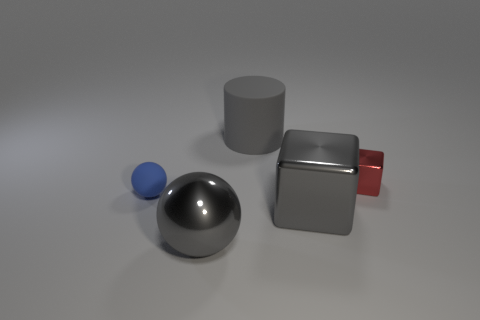Is there any other thing of the same color as the large shiny ball?
Your answer should be compact. Yes. Is the number of big cylinders on the left side of the gray metallic block greater than the number of big green rubber things?
Provide a succinct answer. Yes. How many objects are either things in front of the big cylinder or gray spheres?
Provide a short and direct response. 4. What number of small red cubes have the same material as the large sphere?
Keep it short and to the point. 1. There is a rubber object that is the same color as the big shiny sphere; what shape is it?
Provide a short and direct response. Cylinder. Is there a metallic thing that has the same shape as the blue rubber thing?
Your answer should be compact. Yes. There is a metallic object that is the same size as the gray metal cube; what shape is it?
Offer a very short reply. Sphere. There is a matte cylinder; is its color the same as the block in front of the red metallic block?
Your answer should be very brief. Yes. There is a gray sphere that is in front of the large shiny cube; how many large gray metal objects are behind it?
Your answer should be compact. 1. There is a gray object that is both behind the large sphere and in front of the tiny blue thing; what is its size?
Ensure brevity in your answer.  Large. 